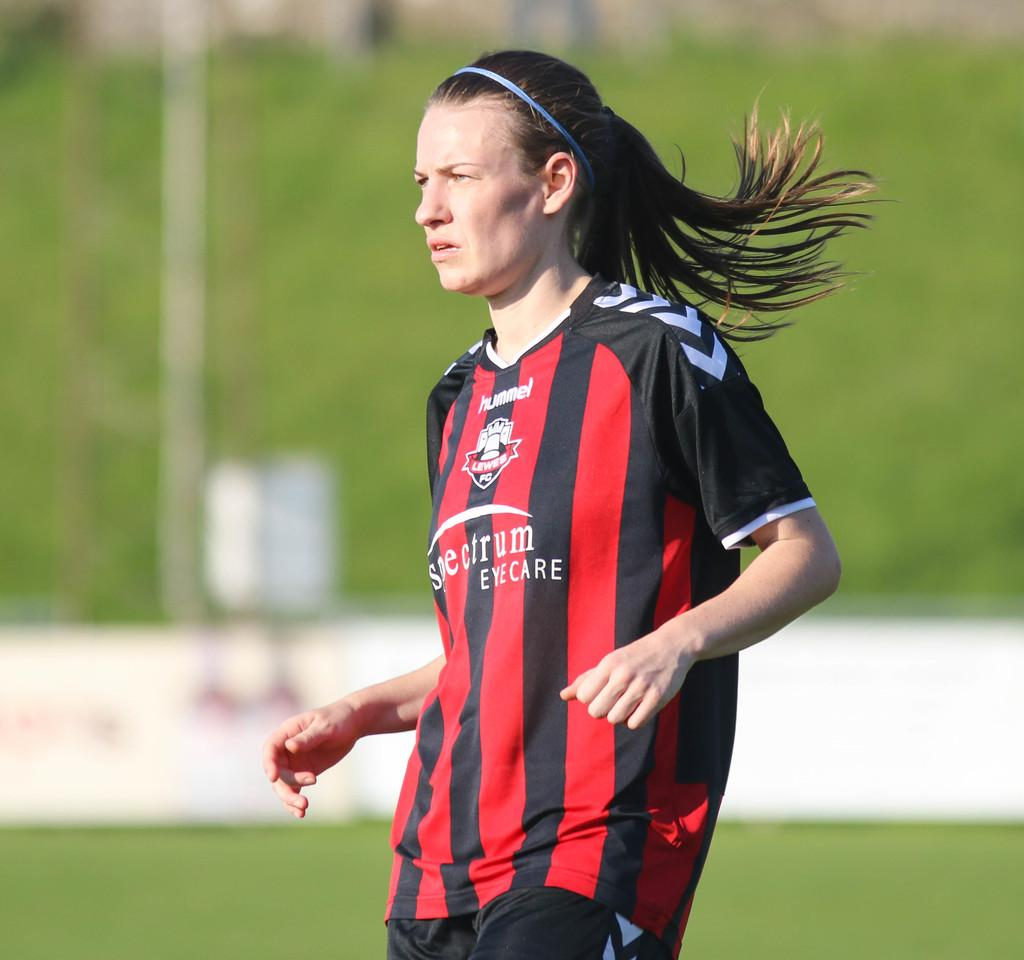Provide a one-sentence caption for the provided image. a person in a black and red striped jersey reading EYE CARE. 